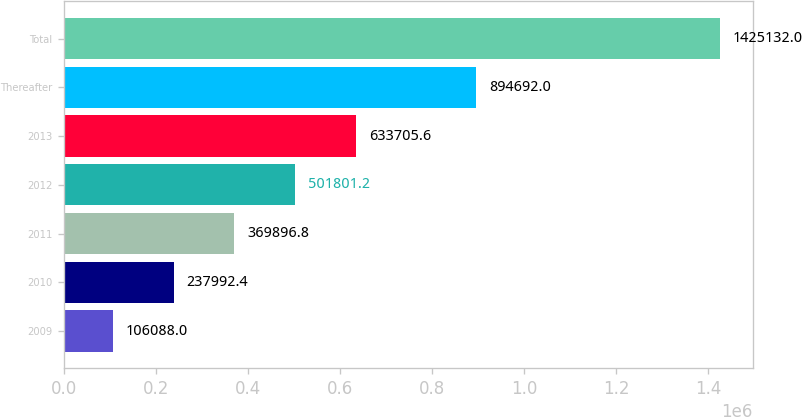Convert chart to OTSL. <chart><loc_0><loc_0><loc_500><loc_500><bar_chart><fcel>2009<fcel>2010<fcel>2011<fcel>2012<fcel>2013<fcel>Thereafter<fcel>Total<nl><fcel>106088<fcel>237992<fcel>369897<fcel>501801<fcel>633706<fcel>894692<fcel>1.42513e+06<nl></chart> 